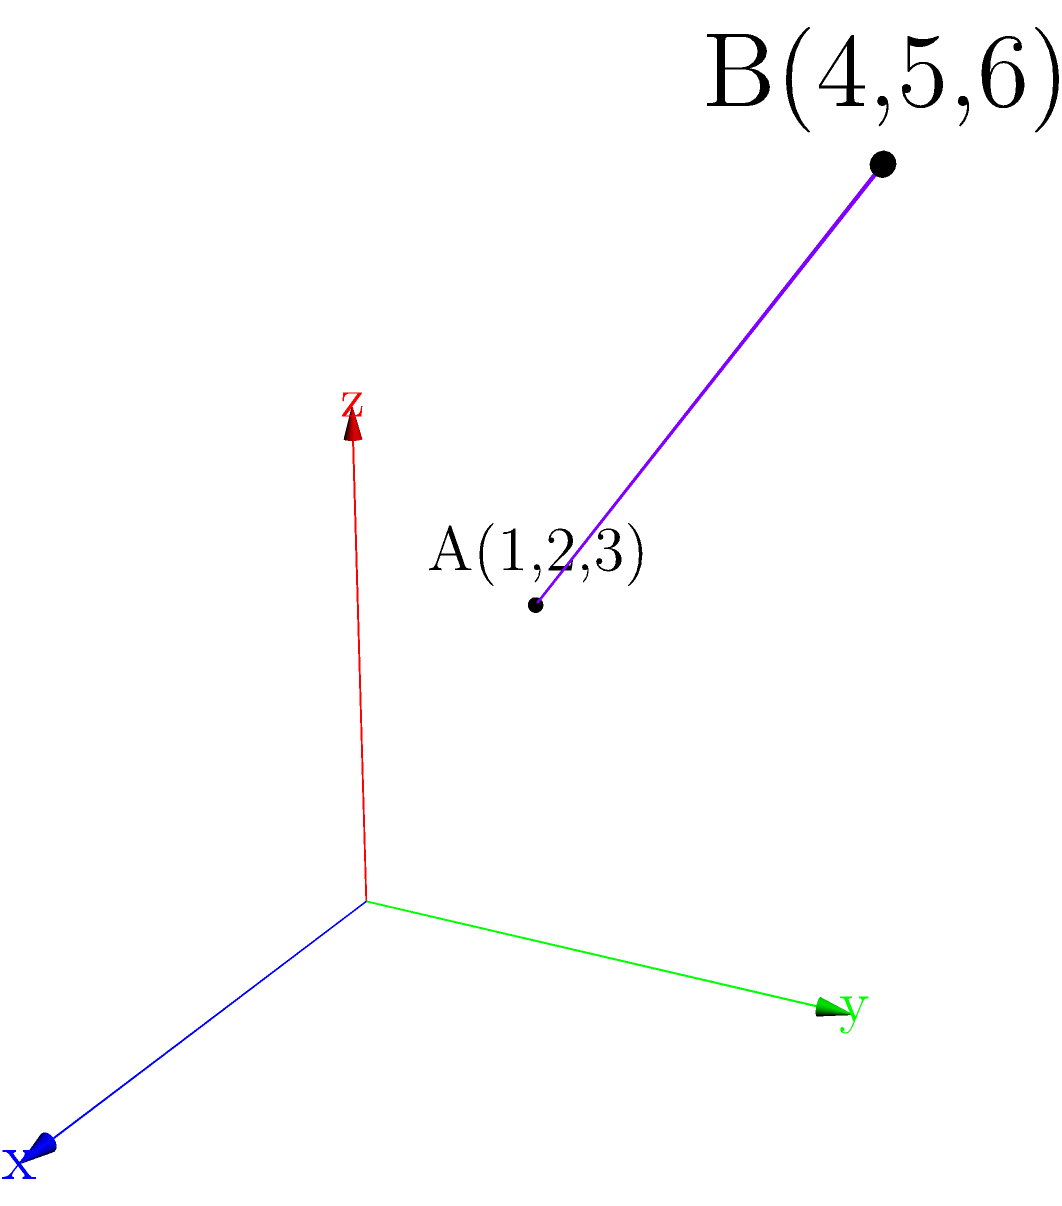In your latest educational e-book on 3D geometry, you want to include an interactive exercise. Consider two points in a 3D coordinate system: $A(1,2,3)$ and $B(4,5,6)$. Calculate the distance between these points to demonstrate the application of the distance formula in three-dimensional space. To find the distance between two points in a 3D coordinate system, we use the three-dimensional distance formula:

$$d = \sqrt{(x_2-x_1)^2 + (y_2-y_1)^2 + (z_2-z_1)^2}$$

Where $(x_1,y_1,z_1)$ are the coordinates of the first point and $(x_2,y_2,z_2)$ are the coordinates of the second point.

Let's apply this formula to our points $A(1,2,3)$ and $B(4,5,6)$:

1) Identify the coordinates:
   $x_1 = 1$, $y_1 = 2$, $z_1 = 3$
   $x_2 = 4$, $y_2 = 5$, $z_2 = 6$

2) Substitute these values into the formula:
   $$d = \sqrt{(4-1)^2 + (5-2)^2 + (6-3)^2}$$

3) Simplify the expressions inside the parentheses:
   $$d = \sqrt{3^2 + 3^2 + 3^2}$$

4) Calculate the squares:
   $$d = \sqrt{9 + 9 + 9}$$

5) Sum up under the square root:
   $$d = \sqrt{27}$$

6) Simplify the square root:
   $$d = 3\sqrt{3}$$

Therefore, the distance between points $A$ and $B$ is $3\sqrt{3}$ units.
Answer: $3\sqrt{3}$ units 